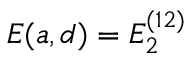<formula> <loc_0><loc_0><loc_500><loc_500>E ( a , d ) = E _ { 2 } ^ { ( 1 2 ) }</formula> 